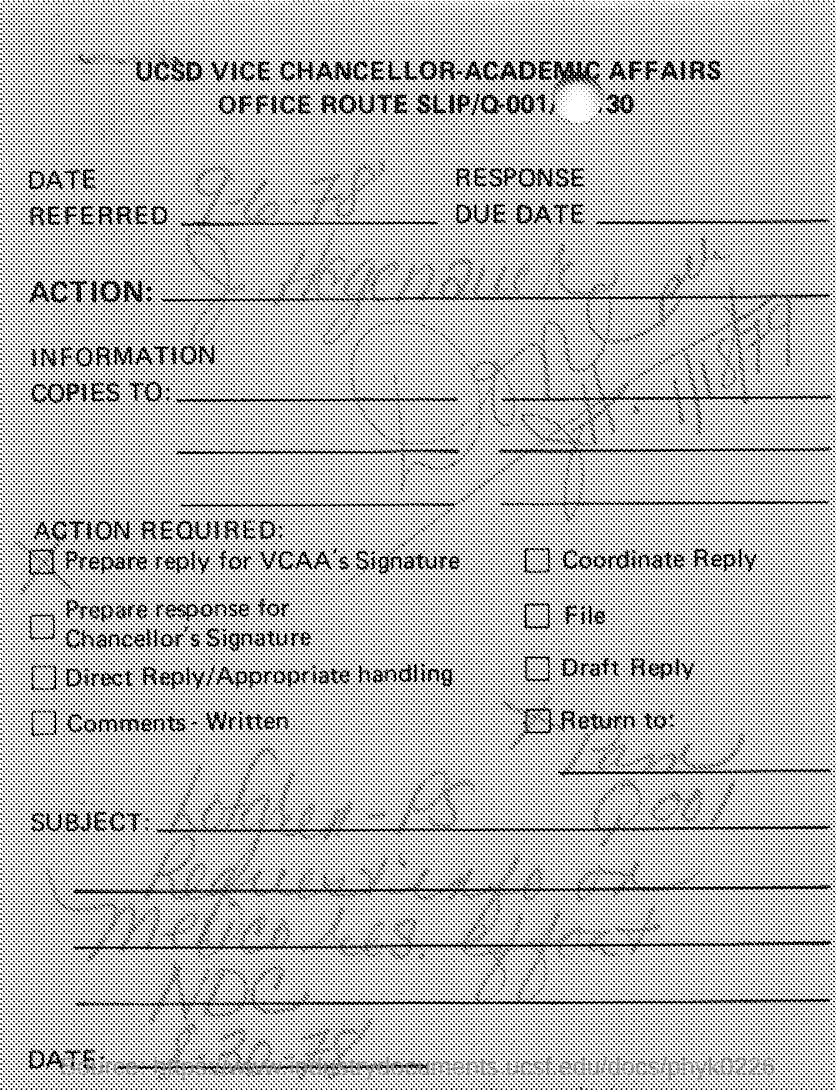What is the Date Referred as per the document?
Make the answer very short. 9-6-78. 